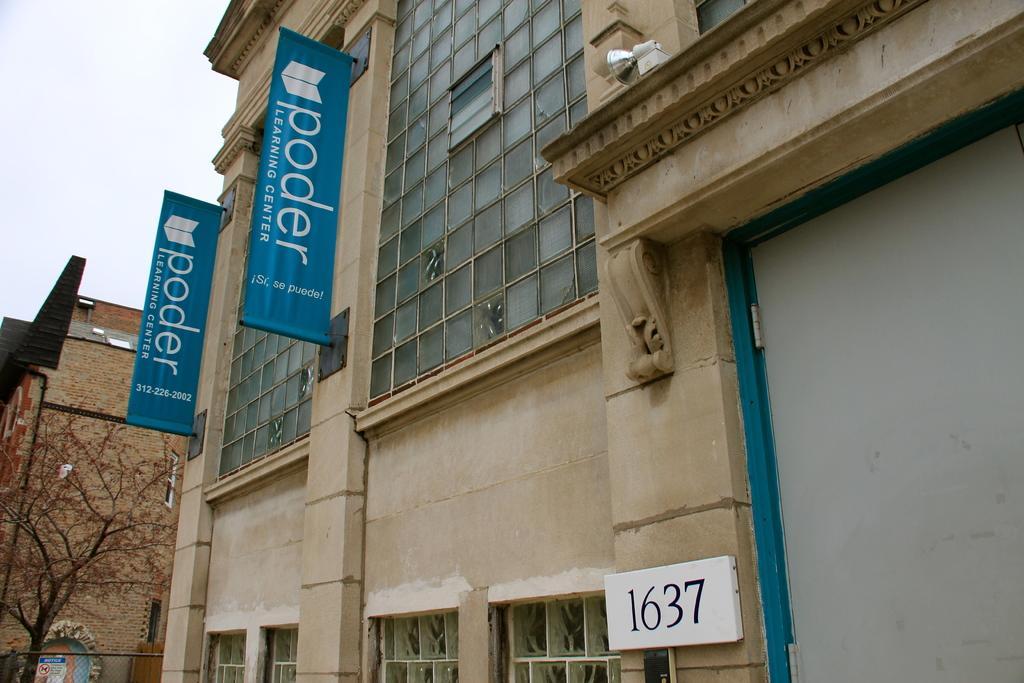Please provide a concise description of this image. In this image there are buildings, in one of the buildings there are posters and there are glass walls, in the left side there is a tree. 